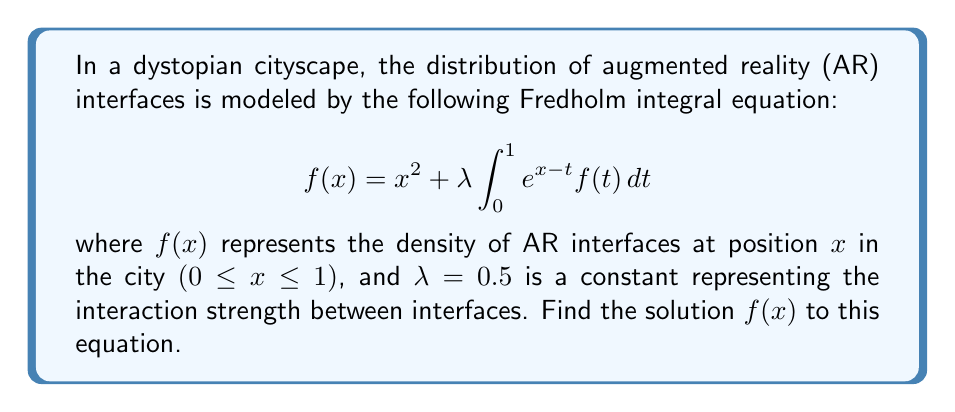Solve this math problem. To solve this Fredholm integral equation, we'll follow these steps:

1) First, assume that the solution has the form:
   $$f(x) = ax^2 + bx + c$$
   where $a$, $b$, and $c$ are constants to be determined.

2) Substitute this into the right-hand side of the equation:
   $$x^2 + \lambda \int_0^1 e^{x-t} (at^2 + bt + c) dt$$

3) Evaluate the integral:
   $$x^2 + \lambda e^x \int_0^1 e^{-t} (at^2 + bt + c) dt$$
   $$= x^2 + \lambda e^x [(-at^2 - bt - c)e^{-t} - (2at + b)e^{-t} - 2ae^{-t}]_0^1$$
   $$= x^2 + \lambda e^x [(2a + b + c)(1 - e^{-1}) - 2a(1 - e^{-1}) - b(1 - e^{-1})]$$
   $$= x^2 + \lambda e^x [c(1 - e^{-1})]$$
   $$= x^2 + \lambda c e^x (1 - e^{-1})$$

4) This should equal our assumed form of $f(x)$. Comparing coefficients:
   $$ax^2 + bx + c = x^2 + \lambda c e^x (1 - e^{-1})$$

5) Comparing coefficients of $x^2$: $a = 1$

6) Comparing coefficients of $x$: $b = \lambda c (1 - e^{-1})$

7) Comparing constant terms: $c = \lambda c (1 - e^{-1})$

8) From the last equation:
   $$c[1 - \lambda(1 - e^{-1})] = 0$$
   Since $\lambda = 0.5$, we get:
   $$c[1 - 0.5(1 - e^{-1})] = 0$$
   $$c \approx 0$$

9) Therefore, $b = 0$ as well.

10) The solution is thus:
    $$f(x) = x^2$$
Answer: $f(x) = x^2$ 